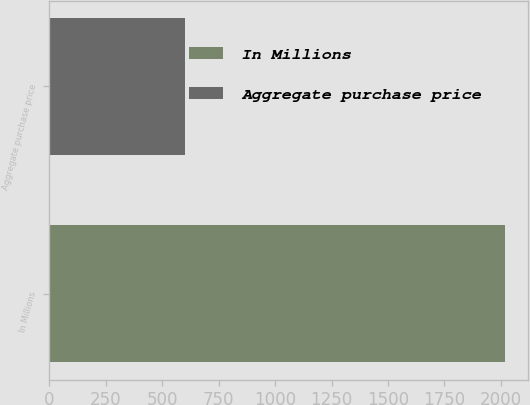Convert chart to OTSL. <chart><loc_0><loc_0><loc_500><loc_500><bar_chart><fcel>In Millions<fcel>Aggregate purchase price<nl><fcel>2018<fcel>601.6<nl></chart> 